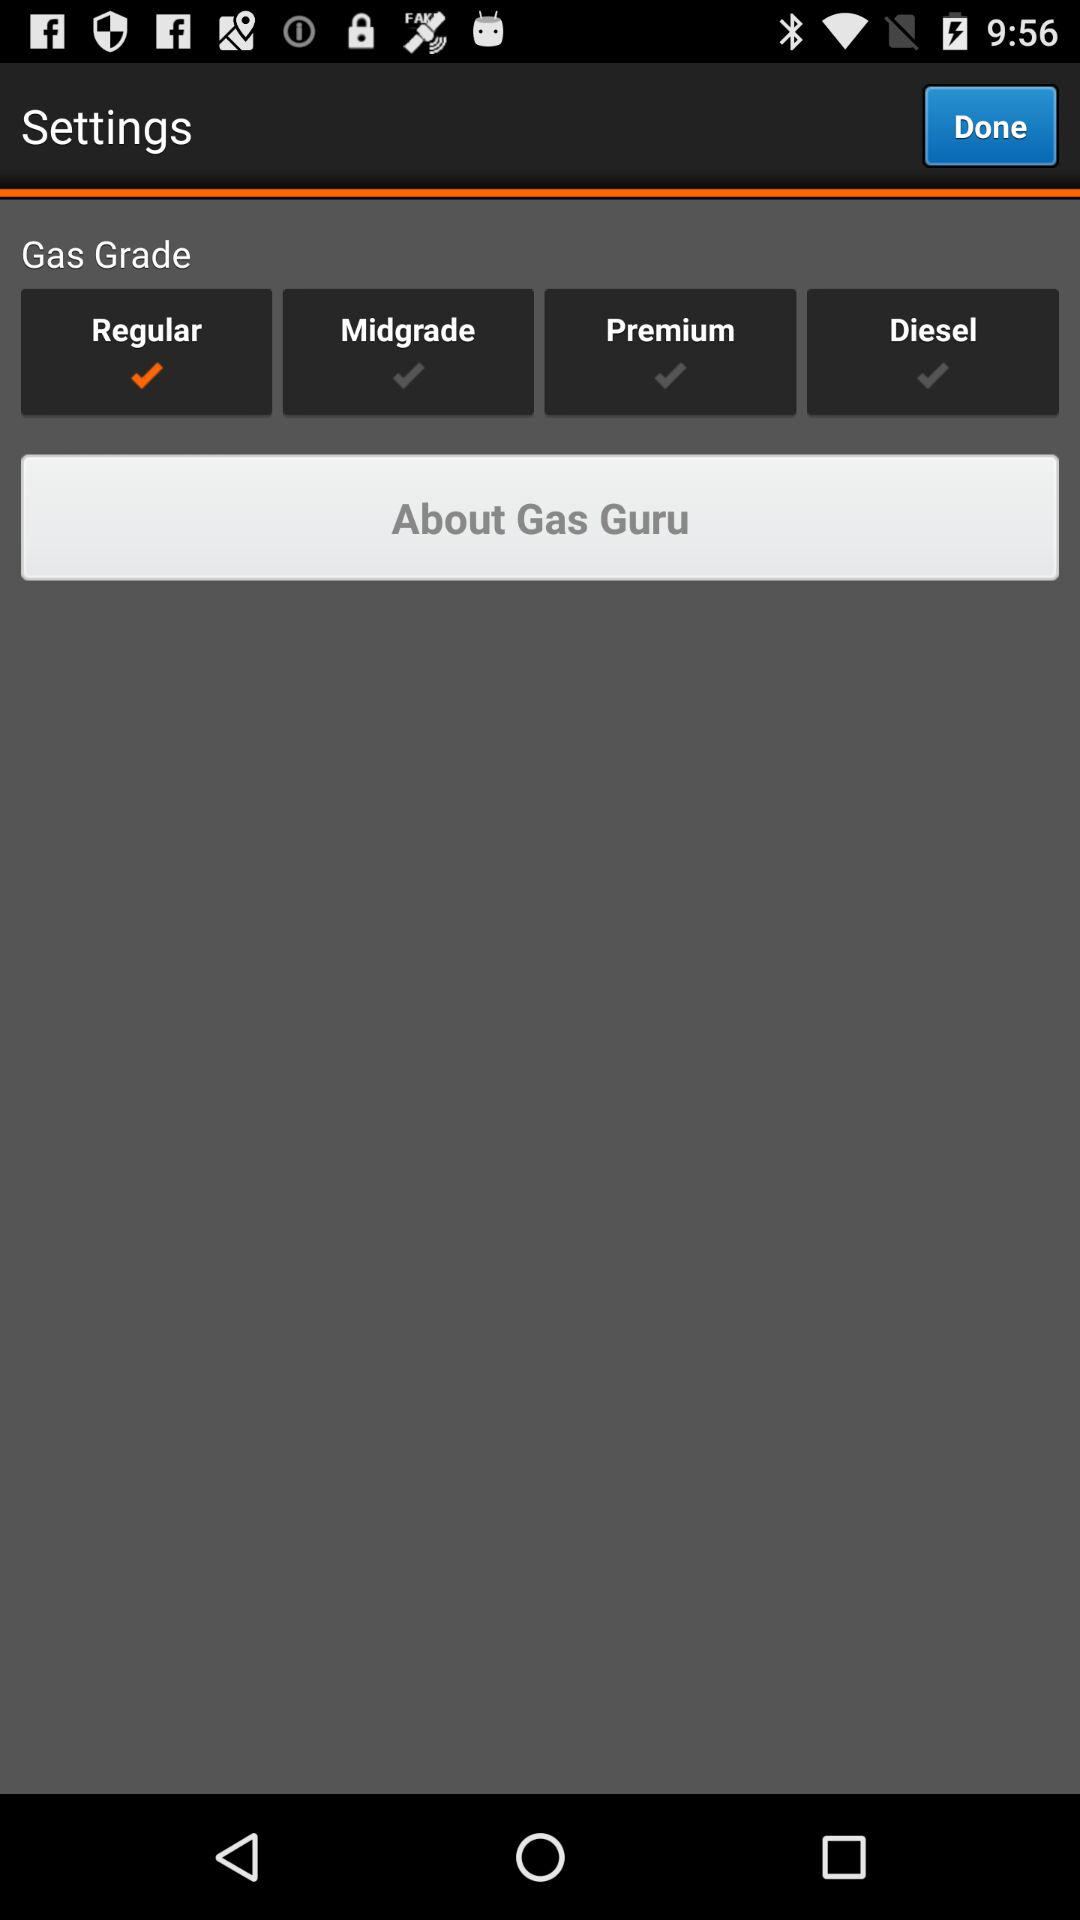Which gas grade has been selected? The selected gas grade is regular. 